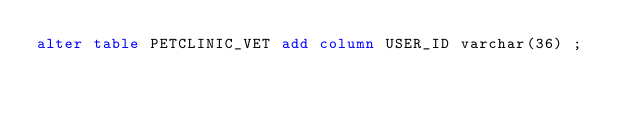<code> <loc_0><loc_0><loc_500><loc_500><_SQL_>alter table PETCLINIC_VET add column USER_ID varchar(36) ;
</code> 